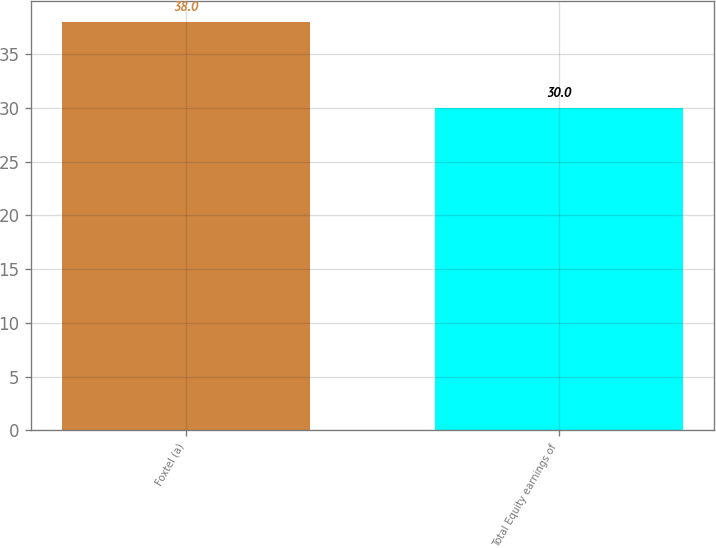<chart> <loc_0><loc_0><loc_500><loc_500><bar_chart><fcel>Foxtel (a)<fcel>Total Equity earnings of<nl><fcel>38<fcel>30<nl></chart> 